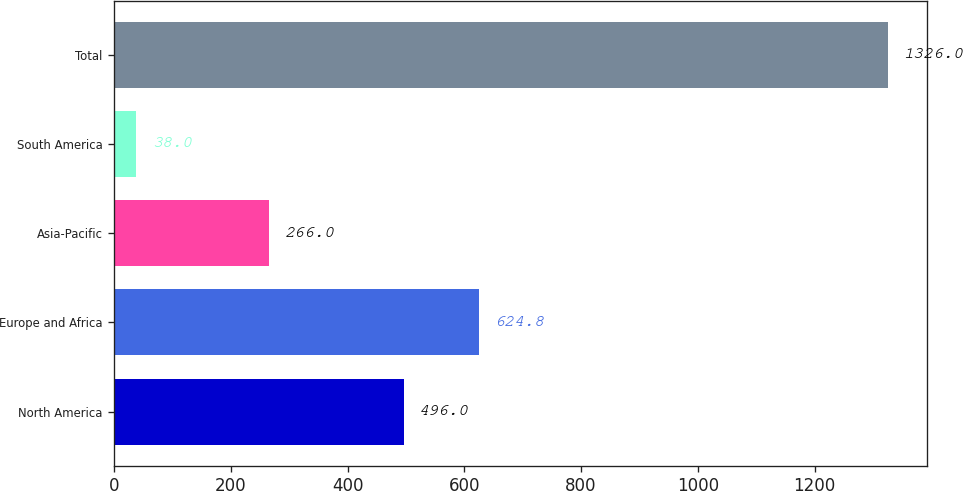Convert chart. <chart><loc_0><loc_0><loc_500><loc_500><bar_chart><fcel>North America<fcel>Europe and Africa<fcel>Asia-Pacific<fcel>South America<fcel>Total<nl><fcel>496<fcel>624.8<fcel>266<fcel>38<fcel>1326<nl></chart> 